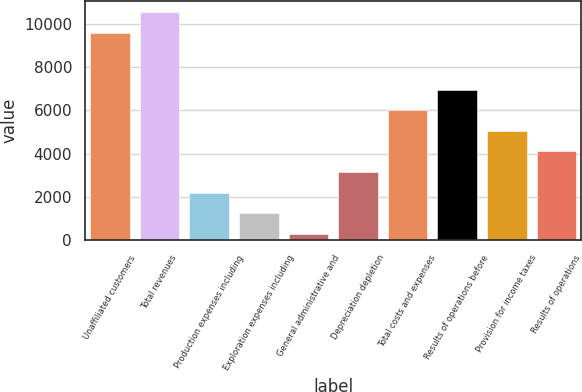Convert chart. <chart><loc_0><loc_0><loc_500><loc_500><bar_chart><fcel>Unaffiliated customers<fcel>Total revenues<fcel>Production expenses including<fcel>Exploration expenses including<fcel>General administrative and<fcel>Depreciation depletion<fcel>Total costs and expenses<fcel>Results of operations before<fcel>Provision for income taxes<fcel>Results of operations<nl><fcel>9569<fcel>10519.4<fcel>2202.8<fcel>1252.4<fcel>302<fcel>3153.2<fcel>6004.4<fcel>6954.8<fcel>5054<fcel>4103.6<nl></chart> 